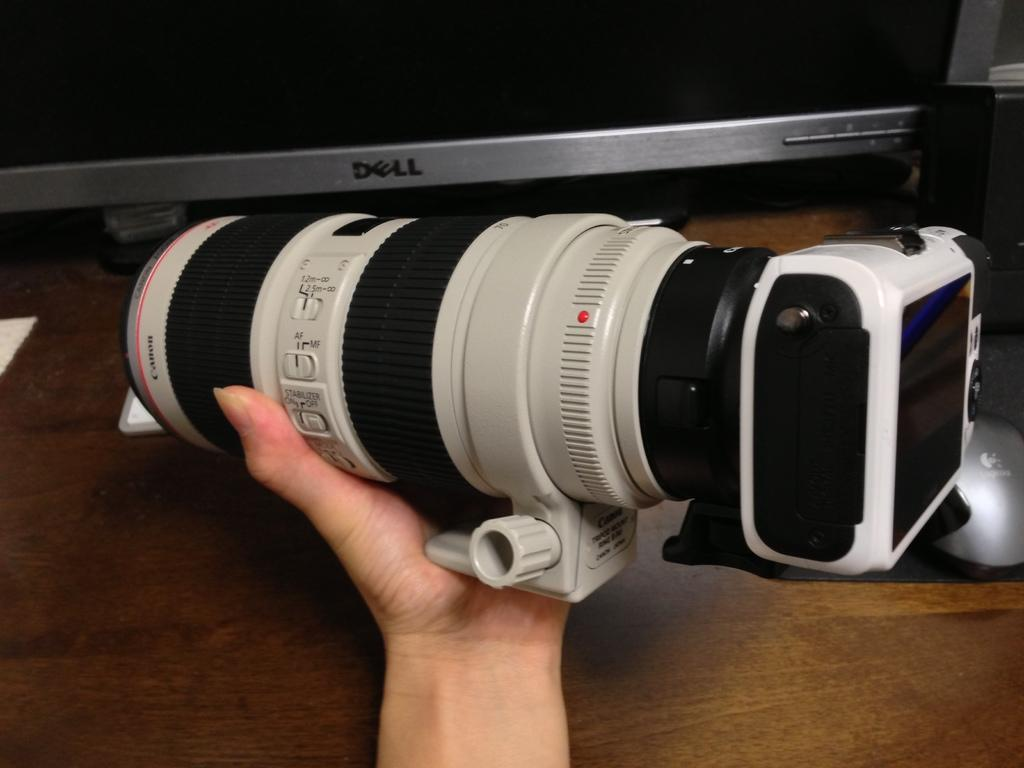What is the person's hand holding in the image? The person's hand is holding a camera in the image. What can be seen behind the hand in the image? There is a computer visible behind the hand in the image. What is the surface that the hand and computer are resting on in the image? There is a table at the bottom of the image. What type of operation is being performed on the person's stomach in the image? There is no indication of any operation or stomach in the image; it primarily features a hand holding a camera and a computer. 